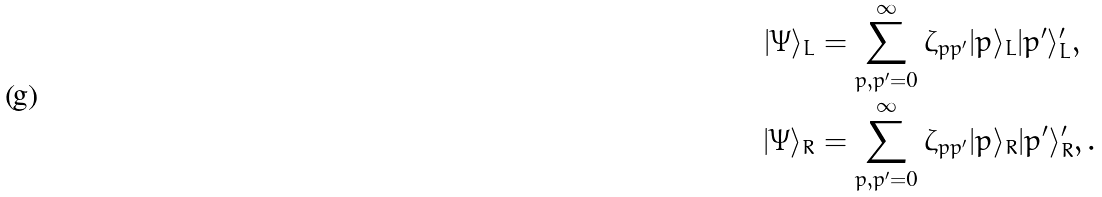Convert formula to latex. <formula><loc_0><loc_0><loc_500><loc_500>| \Psi \rangle _ { L } & = \sum _ { p , p ^ { \prime } = 0 } ^ { \infty } \zeta _ { p p ^ { \prime } } | p \rangle _ { L } | p ^ { \prime } \rangle _ { L } ^ { \prime } , \\ | \Psi \rangle _ { R } & = \sum _ { p , p ^ { \prime } = 0 } ^ { \infty } \zeta _ { p p ^ { \prime } } | p \rangle _ { R } | p ^ { \prime } \rangle _ { R } ^ { \prime } , .</formula> 